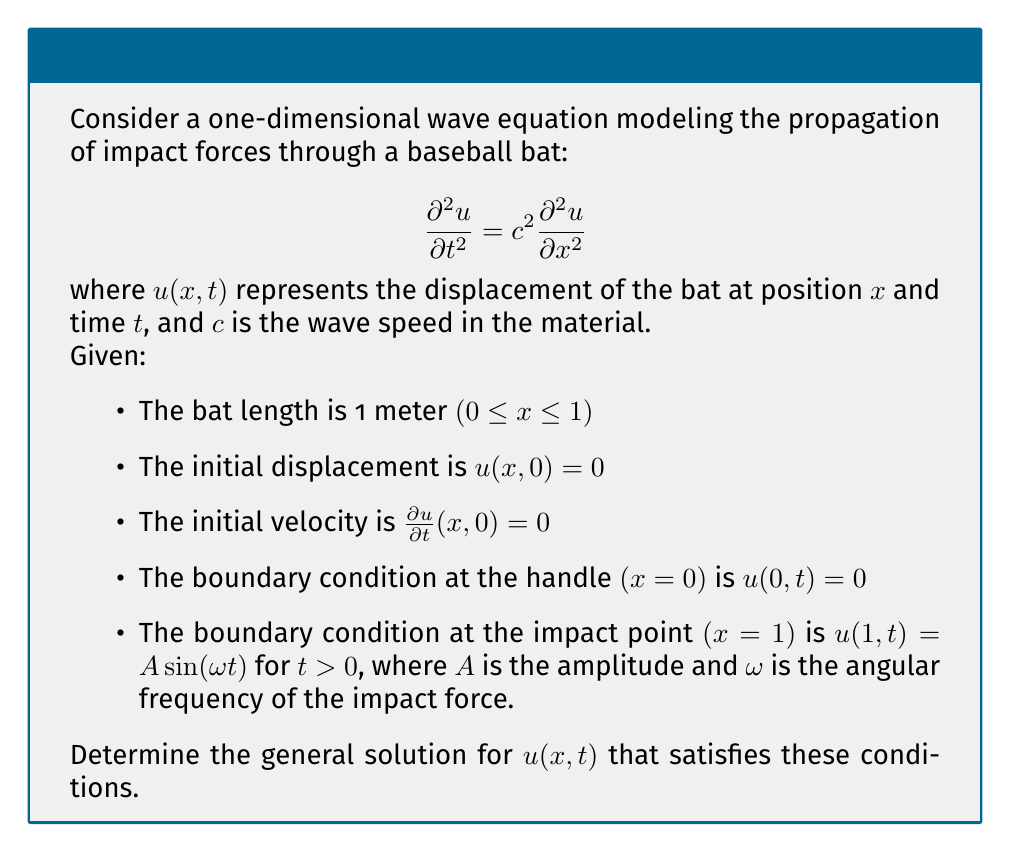Teach me how to tackle this problem. To solve this problem, we'll follow these steps:

1) The general solution of the wave equation is given by d'Alembert's formula:
   $$u(x,t) = f(x-ct) + g(x+ct)$$
   where $f$ and $g$ are arbitrary functions.

2) Given the boundary condition at x = 0, we can write:
   $$u(0,t) = f(-ct) + g(ct) = 0$$
   This implies $f(-ct) = -g(ct)$ for all $t$.

3) Let's define $h(z) = g(z)$. Then $f(z) = -h(-z)$, and our solution becomes:
   $$u(x,t) = h(x+ct) - h(-x+ct)$$

4) Now, we use the boundary condition at x = 1:
   $$u(1,t) = h(1+ct) - h(-1+ct) = A \sin(\omega t)$$

5) To satisfy this, we can choose:
   $$h(z) = \frac{A}{2} \sin(\omega (z-1)/c)$$

6) Substituting this back into our general solution:
   $$u(x,t) = \frac{A}{2} [\sin(\omega (x+ct-1)/c) - \sin(\omega (-x+ct-1)/c)]$$

7) Using the trigonometric identity for the difference of sines, we get:
   $$u(x,t) = A \sin(\omega x/c) \sin(\omega (t-1/c))$$

8) This solution satisfies the initial conditions:
   At $t = 0$: $u(x,0) = A \sin(\omega x/c) \sin(-\omega/c) = 0$
   At $t = 0$: $\frac{\partial u}{\partial t}(x,0) = A\omega \sin(\omega x/c) \cos(-\omega/c) = 0$

Therefore, the general solution satisfying all given conditions is:
$$u(x,t) = A \sin(\omega x/c) \sin(\omega (t-1/c))$$
Answer: $u(x,t) = A \sin(\omega x/c) \sin(\omega (t-1/c))$ 